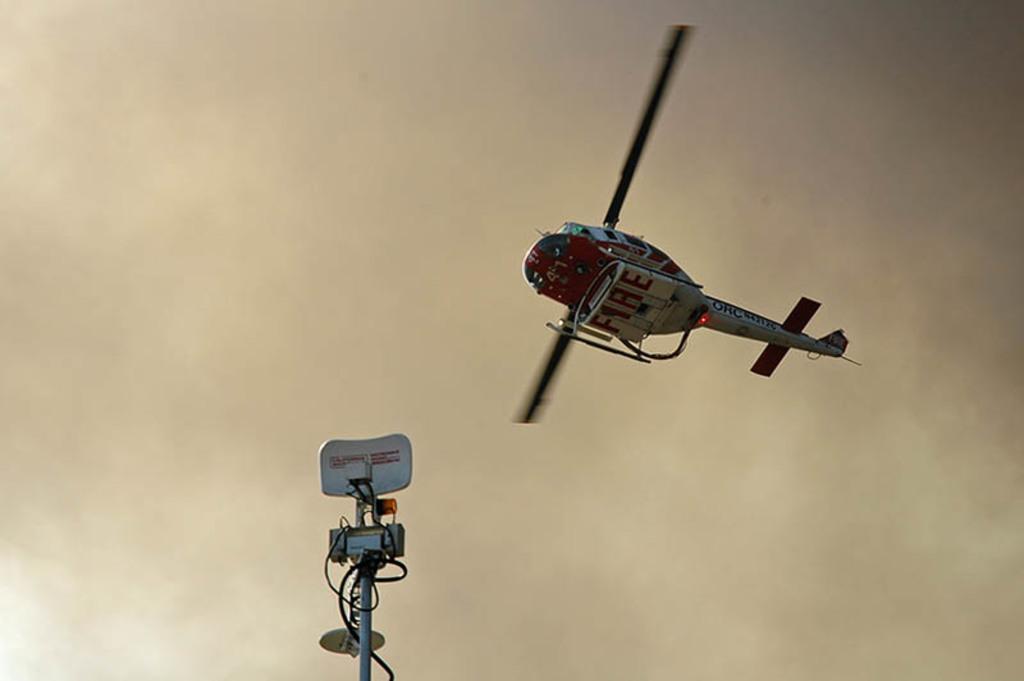To what department does the helicopter belong?
Keep it short and to the point. Fire. 